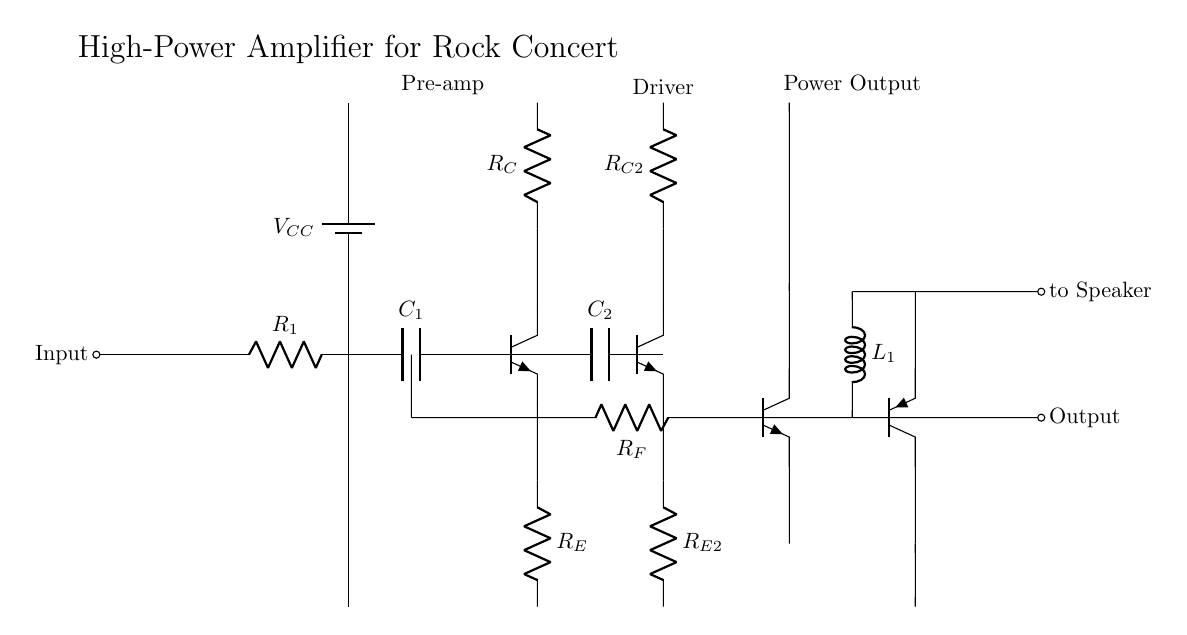What is the power supply voltage labeled in the circuit? The power supply voltage is denoted as V_CC, which represents the high voltage provided to power the amplifier circuit. This voltage is essential for the operation of the transistors and other components in the amplifier.
Answer: V_CC What is the purpose of capacitor C_1 in this circuit? Capacitor C_1 is connected in series with resistor R_1, thus it serves to couple the input signal and block any DC component, allowing only AC signals to pass through to the pre-amp stage. This is critical for audio applications to ensure only the desired audio signals are amplified.
Answer: Coupling How many transistors are present in this amplifier circuit? Counting the transistors in the circuit, we see three NPN transistors (Q1, Q2, Q3) and one PNP transistor (Q4), making a total of four transistors. Each transistor plays a role in amplifying the input signal through different stages of the amplifier.
Answer: Four What type of amplification stage is directly after the pre-amplifier stage? The diagram shows that the driver stage follows the pre-amplifier stage, indicated by the connection from the output of the pre-amplifier (after capacitor C_2) to the base of transistor Q2. This stage is crucial for increasing the current of the signal before it is sent to the power output stage.
Answer: Driver What component is used for feedback in the output stage of this circuit? Resistor R_F is used for feedback in the circuit, connecting the output stage back to the pre-amp section. Feedback helps stabilize the amplifier's gain and improves linearity, reducing distortion in the amplified signal.
Answer: Resistor R_F Which component is responsible for blocking DC while allowing AC signals to pass at the output? The inductor L_1 at the output serves to block DC and allow AC signals to pass through to the speaker. This is important in audio amplification systems to prevent DC from damaging the speaker while effectively transmitting the amplified audio signal.
Answer: Inductor L_1 What is the function of the coupling capacitor C_2 in the circuit? Coupling capacitor C_2 connects the output of the pre-amplifier to the driver stage, allowing AC signals to pass through while blocking any DC component. This ensures that only the varying audio signals are amplified in the following stage, maintaining audio fidelity.
Answer: Coupling 